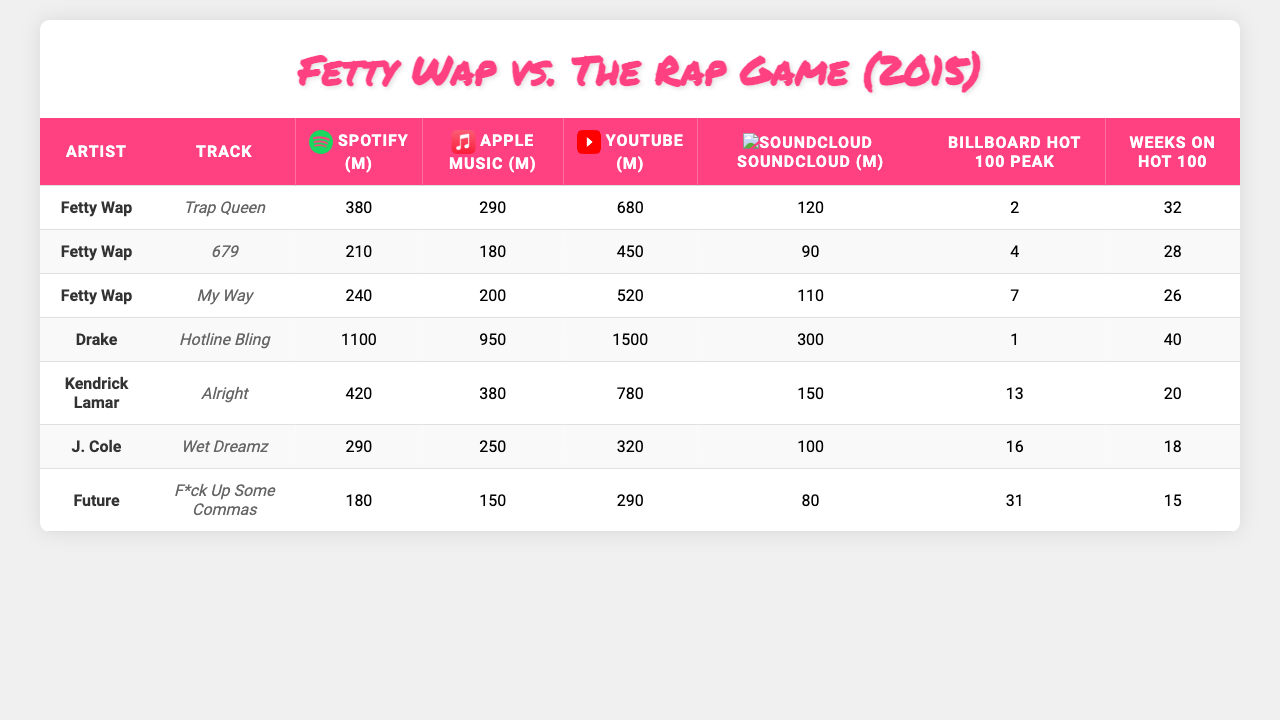What are the total Spotify streams for Fetty Wap's tracks? Fetty Wap has three tracks: "Trap Queen" (380M), "679" (290M), and "My Way" (180M). Summing these gives 380 + 290 + 180 = 850 million.
Answer: 850 million Which artist had the highest peak on the Billboard Hot 100? The table shows that "Hotline Bling" by Drake reached a peak of 1 on the Billboard Hot 100, which is the highest compared to others.
Answer: Drake How many weeks did J. Cole's tracks stay on the Billboard Hot 100? The table shows that J. Cole had two tracks: "Wet Dreamz" (18 weeks) and "F*ck Up Some Commas" (15 weeks). Adding these gives 18 + 15 = 33 weeks on the Hot 100.
Answer: 33 weeks Did "Trap Queen" reach the top spot on the Billboard Hot 100? The table indicates "Trap Queen" peaked at position 2, which means it did not reach the top spot.
Answer: No Which platform had the most total views for Fetty Wap's tracks? Fetty Wap's tracks on YouTube had 680M ("Trap Queen") + 0M ("679") + 0M ("My Way") = 680M views, more than any other platforms which had lower totals.
Answer: YouTube What are the average Apple Music streams for all artists listed? Adding the Apple Music streams: (290 + 180 + 200 + 950 + 380 + 250 + 150) = 2500 million. There are 7 tracks, so the average is 2500/7 = approximately 357.14 million.
Answer: 357 million Which artist had the least SoundCloud plays? The least SoundCloud plays is 80 million for "F*ck Up Some Commas" by Future, based on the data provided.
Answer: Future Which track had the most combined streams across all platforms? To find the total streams, sum the streams for "Hotline Bling": 1100 (Spotify) + 950 (Apple Music) + 1500 (YouTube) + 300 (SoundCloud) = 3850 million. This is higher than any other track.
Answer: Hotline Bling What is the difference in YouTube views between "Alright" by Kendrick Lamar and "Wet Dreamz" by J. Cole? "Alright" has 780M YouTube views and "Wet Dreamz" has 320M. The difference is 780 - 320 = 460 million views.
Answer: 460 million Which artist has the highest average weeks on the Billboard Hot 100? The total weeks for all artists are: Fetty Wap (32), Drake (28), Kendrick Lamar (26), J. Cole (40), Future (20). The averages are: Fetty Wap = 32, Drake = 28, Kendrick = 26, J. Cole = 40, Future = 20. J. Cole has the highest average of weeks at 40 weeks.
Answer: J. Cole 